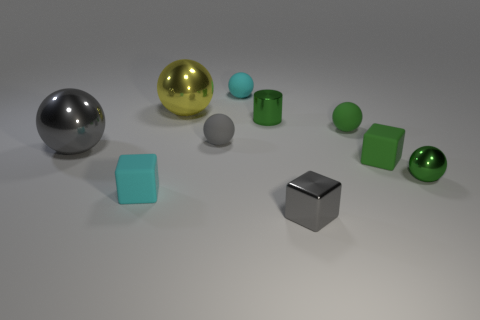Subtract all cyan spheres. How many spheres are left? 5 Subtract all green matte spheres. How many spheres are left? 5 Subtract all yellow spheres. Subtract all green cylinders. How many spheres are left? 5 Subtract all spheres. How many objects are left? 4 Subtract all green things. Subtract all small rubber balls. How many objects are left? 3 Add 1 tiny cyan matte cubes. How many tiny cyan matte cubes are left? 2 Add 8 tiny green metal spheres. How many tiny green metal spheres exist? 9 Subtract 0 brown cylinders. How many objects are left? 10 